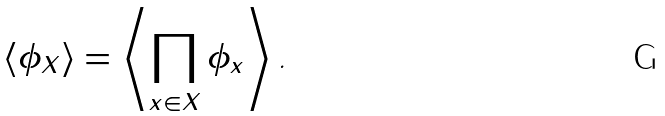<formula> <loc_0><loc_0><loc_500><loc_500>\left \langle \phi _ { X } \right \rangle = \left \langle \prod _ { x \in X } \phi _ { x } \right \rangle \text {.}</formula> 